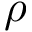<formula> <loc_0><loc_0><loc_500><loc_500>\rho</formula> 